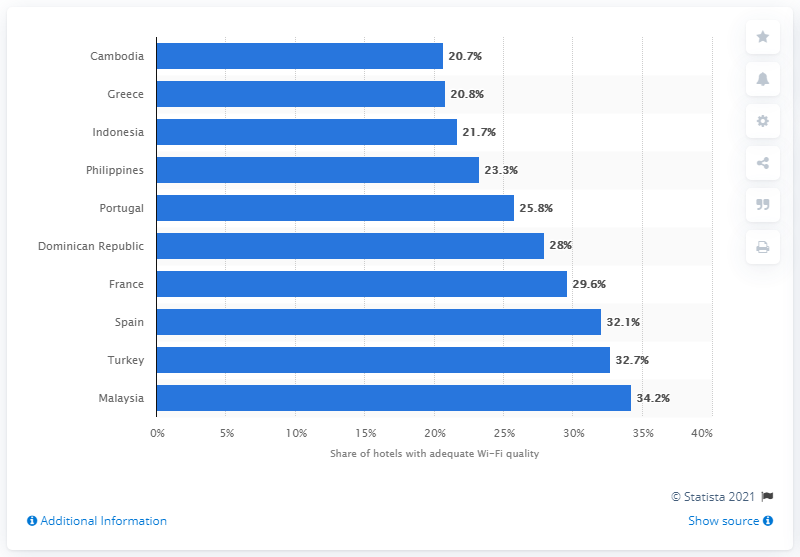Specify some key components in this picture. According to a recent study, the country with the poorest hotel Wi-Fi quality is Cambodia. 